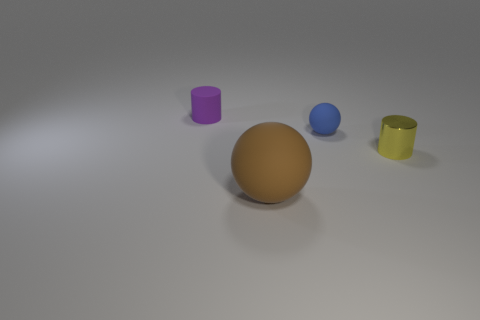How many other things are there of the same color as the small rubber ball?
Give a very brief answer. 0. Are there any other things that are the same size as the brown ball?
Ensure brevity in your answer.  No. What number of objects are rubber spheres that are right of the big brown rubber sphere or cylinders to the right of the large brown ball?
Your response must be concise. 2. Is there a brown rubber cylinder that has the same size as the yellow thing?
Provide a short and direct response. No. What is the color of the small matte thing that is the same shape as the small yellow metal thing?
Provide a short and direct response. Purple. There is a cylinder in front of the tiny purple cylinder; is there a object that is behind it?
Give a very brief answer. Yes. There is a matte object that is in front of the shiny thing; does it have the same shape as the small yellow thing?
Make the answer very short. No. There is a blue matte thing; what shape is it?
Offer a very short reply. Sphere. How many yellow cylinders are the same material as the yellow object?
Give a very brief answer. 0. What number of shiny spheres are there?
Keep it short and to the point. 0. 